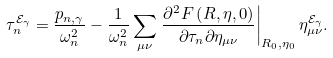<formula> <loc_0><loc_0><loc_500><loc_500>\tau _ { n } ^ { \mathcal { E } _ { \gamma } } = \frac { p _ { n , \gamma } } { \omega _ { n } ^ { 2 } } - \frac { 1 } { \omega _ { n } ^ { 2 } } \sum _ { \mu \nu } \left . \frac { \partial ^ { 2 } F \left ( R , \eta , 0 \right ) } { \partial \tau _ { n } \partial \eta _ { \mu \nu } } \right | _ { R _ { 0 } , \eta _ { 0 } } \eta _ { \mu \nu } ^ { \mathcal { E } _ { \gamma } } .</formula> 